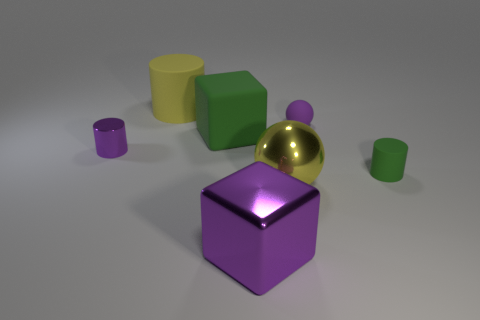Subtract all tiny purple cylinders. How many cylinders are left? 2 Add 1 green rubber things. How many objects exist? 8 Subtract all yellow cylinders. How many cylinders are left? 2 Subtract all cylinders. How many objects are left? 4 Subtract all yellow cylinders. Subtract all yellow matte objects. How many objects are left? 5 Add 1 balls. How many balls are left? 3 Add 3 yellow rubber objects. How many yellow rubber objects exist? 4 Subtract 0 gray spheres. How many objects are left? 7 Subtract all yellow cylinders. Subtract all purple balls. How many cylinders are left? 2 